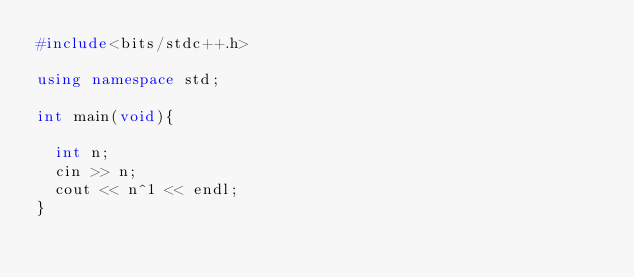Convert code to text. <code><loc_0><loc_0><loc_500><loc_500><_C++_>#include<bits/stdc++.h>

using namespace std;

int main(void){
  
  int n;
  cin >> n;
  cout << n^1 << endl;
}</code> 